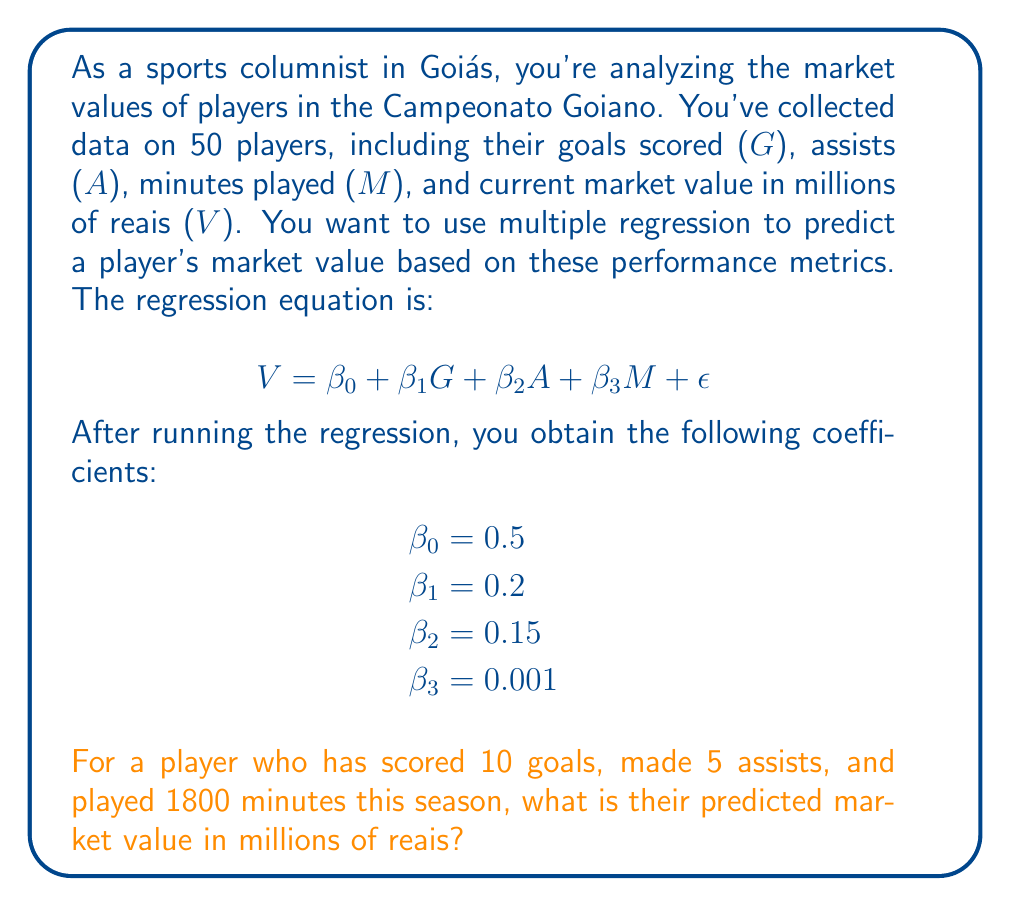What is the answer to this math problem? To solve this problem, we'll follow these steps:

1. Recall the multiple regression equation:
   $$V = \beta_0 + \beta_1G + \beta_2A + \beta_3M + \epsilon$$

2. Substitute the given coefficient values:
   $$V = 0.5 + 0.2G + 0.15A + 0.001M$$

3. Now, let's plug in the player's statistics:
   - G (goals) = 10
   - A (assists) = 5
   - M (minutes played) = 1800

4. Calculate the predicted market value:
   $$V = 0.5 + 0.2(10) + 0.15(5) + 0.001(1800)$$

5. Solve the equation:
   $$V = 0.5 + 2 + 0.75 + 1.8$$
   $$V = 5.05$$

Therefore, the predicted market value for this player is 5.05 million reais.
Answer: 5.05 million reais 